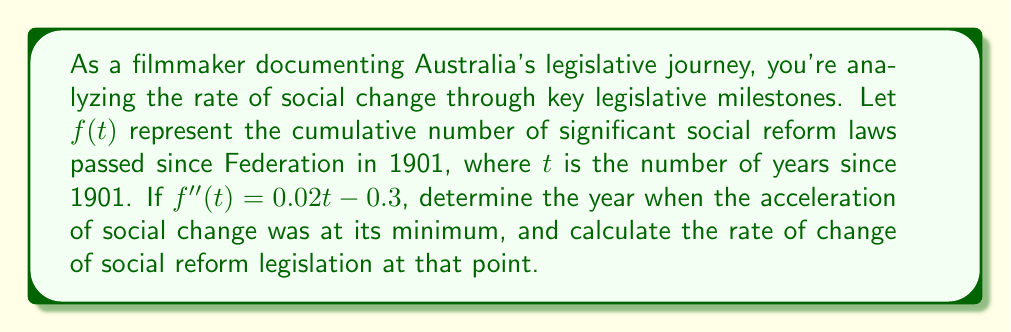Help me with this question. 1) The second derivative $f''(t)$ represents the acceleration of social change. We're given:

   $$f''(t) = 0.02t - 0.3$$

2) To find the minimum acceleration, we need to find where $f''(t) = 0$:

   $$0.02t - 0.3 = 0$$
   $$0.02t = 0.3$$
   $$t = 15$$

3) This means the minimum acceleration occurred 15 years after 1901, which is 1916.

4) To find the rate of change at this point, we need to integrate $f''(t)$ to get $f'(t)$:

   $$f'(t) = \int f''(t) dt = \int (0.02t - 0.3) dt = 0.01t^2 - 0.3t + C$$

5) We don't need to determine the constant $C$ as it will not affect the rate of change.

6) Now, we evaluate $f'(15)$:

   $$f'(15) = 0.01(15)^2 - 0.3(15) = 2.25 - 4.5 = -2.25$$

7) The negative value indicates that the rate of social reform legislation was actually decreasing at this point, at a rate of 2.25 laws per year.
Answer: Minimum acceleration: 1916; Rate of change: -2.25 laws/year 